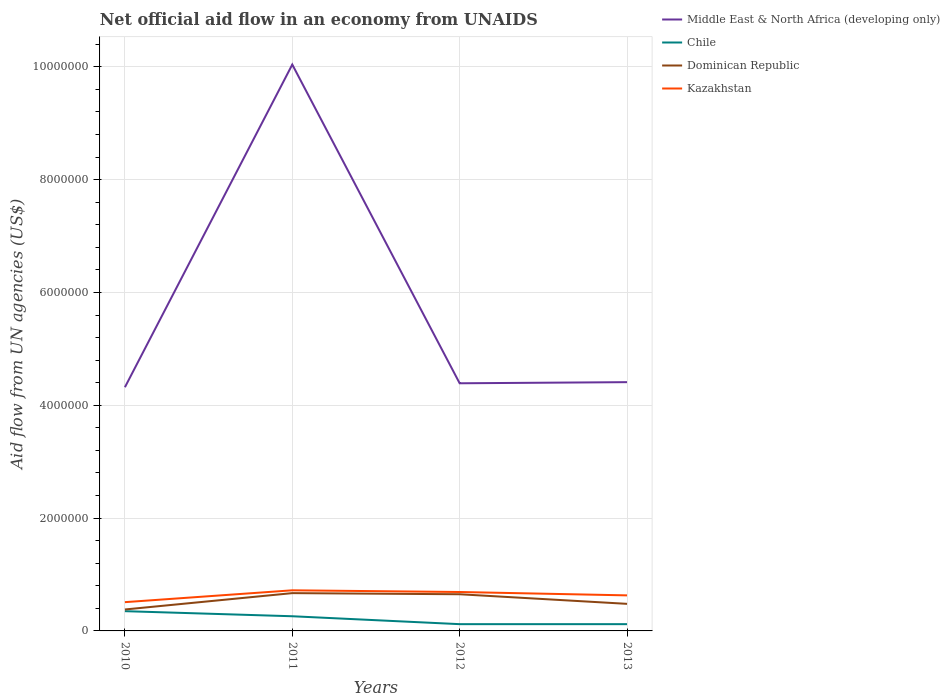Does the line corresponding to Chile intersect with the line corresponding to Middle East & North Africa (developing only)?
Ensure brevity in your answer.  No. Is the number of lines equal to the number of legend labels?
Provide a short and direct response. Yes. Across all years, what is the maximum net official aid flow in Dominican Republic?
Provide a short and direct response. 3.80e+05. What is the total net official aid flow in Kazakhstan in the graph?
Keep it short and to the point. 3.00e+04. What is the difference between the highest and the second highest net official aid flow in Dominican Republic?
Offer a very short reply. 2.90e+05. How many lines are there?
Offer a terse response. 4. How many years are there in the graph?
Provide a short and direct response. 4. What is the difference between two consecutive major ticks on the Y-axis?
Offer a very short reply. 2.00e+06. Are the values on the major ticks of Y-axis written in scientific E-notation?
Your answer should be very brief. No. Does the graph contain grids?
Make the answer very short. Yes. What is the title of the graph?
Offer a terse response. Net official aid flow in an economy from UNAIDS. Does "Eritrea" appear as one of the legend labels in the graph?
Keep it short and to the point. No. What is the label or title of the Y-axis?
Provide a short and direct response. Aid flow from UN agencies (US$). What is the Aid flow from UN agencies (US$) of Middle East & North Africa (developing only) in 2010?
Give a very brief answer. 4.32e+06. What is the Aid flow from UN agencies (US$) in Kazakhstan in 2010?
Ensure brevity in your answer.  5.10e+05. What is the Aid flow from UN agencies (US$) of Middle East & North Africa (developing only) in 2011?
Make the answer very short. 1.00e+07. What is the Aid flow from UN agencies (US$) of Dominican Republic in 2011?
Provide a succinct answer. 6.70e+05. What is the Aid flow from UN agencies (US$) of Kazakhstan in 2011?
Your answer should be compact. 7.20e+05. What is the Aid flow from UN agencies (US$) of Middle East & North Africa (developing only) in 2012?
Your answer should be compact. 4.39e+06. What is the Aid flow from UN agencies (US$) of Dominican Republic in 2012?
Keep it short and to the point. 6.50e+05. What is the Aid flow from UN agencies (US$) of Kazakhstan in 2012?
Provide a short and direct response. 6.90e+05. What is the Aid flow from UN agencies (US$) in Middle East & North Africa (developing only) in 2013?
Offer a very short reply. 4.41e+06. What is the Aid flow from UN agencies (US$) of Chile in 2013?
Give a very brief answer. 1.20e+05. What is the Aid flow from UN agencies (US$) in Dominican Republic in 2013?
Give a very brief answer. 4.80e+05. What is the Aid flow from UN agencies (US$) of Kazakhstan in 2013?
Offer a very short reply. 6.30e+05. Across all years, what is the maximum Aid flow from UN agencies (US$) in Middle East & North Africa (developing only)?
Give a very brief answer. 1.00e+07. Across all years, what is the maximum Aid flow from UN agencies (US$) in Chile?
Keep it short and to the point. 3.50e+05. Across all years, what is the maximum Aid flow from UN agencies (US$) of Dominican Republic?
Your response must be concise. 6.70e+05. Across all years, what is the maximum Aid flow from UN agencies (US$) in Kazakhstan?
Provide a succinct answer. 7.20e+05. Across all years, what is the minimum Aid flow from UN agencies (US$) of Middle East & North Africa (developing only)?
Provide a succinct answer. 4.32e+06. Across all years, what is the minimum Aid flow from UN agencies (US$) in Chile?
Provide a short and direct response. 1.20e+05. Across all years, what is the minimum Aid flow from UN agencies (US$) in Kazakhstan?
Ensure brevity in your answer.  5.10e+05. What is the total Aid flow from UN agencies (US$) in Middle East & North Africa (developing only) in the graph?
Provide a short and direct response. 2.32e+07. What is the total Aid flow from UN agencies (US$) in Chile in the graph?
Ensure brevity in your answer.  8.50e+05. What is the total Aid flow from UN agencies (US$) in Dominican Republic in the graph?
Provide a succinct answer. 2.18e+06. What is the total Aid flow from UN agencies (US$) of Kazakhstan in the graph?
Your answer should be very brief. 2.55e+06. What is the difference between the Aid flow from UN agencies (US$) in Middle East & North Africa (developing only) in 2010 and that in 2011?
Your answer should be compact. -5.72e+06. What is the difference between the Aid flow from UN agencies (US$) in Dominican Republic in 2010 and that in 2011?
Ensure brevity in your answer.  -2.90e+05. What is the difference between the Aid flow from UN agencies (US$) in Kazakhstan in 2010 and that in 2011?
Your answer should be compact. -2.10e+05. What is the difference between the Aid flow from UN agencies (US$) of Dominican Republic in 2010 and that in 2012?
Make the answer very short. -2.70e+05. What is the difference between the Aid flow from UN agencies (US$) in Kazakhstan in 2010 and that in 2013?
Provide a succinct answer. -1.20e+05. What is the difference between the Aid flow from UN agencies (US$) in Middle East & North Africa (developing only) in 2011 and that in 2012?
Your response must be concise. 5.65e+06. What is the difference between the Aid flow from UN agencies (US$) of Kazakhstan in 2011 and that in 2012?
Make the answer very short. 3.00e+04. What is the difference between the Aid flow from UN agencies (US$) in Middle East & North Africa (developing only) in 2011 and that in 2013?
Offer a terse response. 5.63e+06. What is the difference between the Aid flow from UN agencies (US$) of Chile in 2011 and that in 2013?
Ensure brevity in your answer.  1.40e+05. What is the difference between the Aid flow from UN agencies (US$) in Middle East & North Africa (developing only) in 2012 and that in 2013?
Your response must be concise. -2.00e+04. What is the difference between the Aid flow from UN agencies (US$) in Chile in 2012 and that in 2013?
Give a very brief answer. 0. What is the difference between the Aid flow from UN agencies (US$) of Kazakhstan in 2012 and that in 2013?
Give a very brief answer. 6.00e+04. What is the difference between the Aid flow from UN agencies (US$) in Middle East & North Africa (developing only) in 2010 and the Aid flow from UN agencies (US$) in Chile in 2011?
Your answer should be very brief. 4.06e+06. What is the difference between the Aid flow from UN agencies (US$) in Middle East & North Africa (developing only) in 2010 and the Aid flow from UN agencies (US$) in Dominican Republic in 2011?
Ensure brevity in your answer.  3.65e+06. What is the difference between the Aid flow from UN agencies (US$) in Middle East & North Africa (developing only) in 2010 and the Aid flow from UN agencies (US$) in Kazakhstan in 2011?
Keep it short and to the point. 3.60e+06. What is the difference between the Aid flow from UN agencies (US$) of Chile in 2010 and the Aid flow from UN agencies (US$) of Dominican Republic in 2011?
Ensure brevity in your answer.  -3.20e+05. What is the difference between the Aid flow from UN agencies (US$) of Chile in 2010 and the Aid flow from UN agencies (US$) of Kazakhstan in 2011?
Keep it short and to the point. -3.70e+05. What is the difference between the Aid flow from UN agencies (US$) in Dominican Republic in 2010 and the Aid flow from UN agencies (US$) in Kazakhstan in 2011?
Your response must be concise. -3.40e+05. What is the difference between the Aid flow from UN agencies (US$) of Middle East & North Africa (developing only) in 2010 and the Aid flow from UN agencies (US$) of Chile in 2012?
Your answer should be compact. 4.20e+06. What is the difference between the Aid flow from UN agencies (US$) of Middle East & North Africa (developing only) in 2010 and the Aid flow from UN agencies (US$) of Dominican Republic in 2012?
Give a very brief answer. 3.67e+06. What is the difference between the Aid flow from UN agencies (US$) in Middle East & North Africa (developing only) in 2010 and the Aid flow from UN agencies (US$) in Kazakhstan in 2012?
Keep it short and to the point. 3.63e+06. What is the difference between the Aid flow from UN agencies (US$) in Dominican Republic in 2010 and the Aid flow from UN agencies (US$) in Kazakhstan in 2012?
Your answer should be very brief. -3.10e+05. What is the difference between the Aid flow from UN agencies (US$) of Middle East & North Africa (developing only) in 2010 and the Aid flow from UN agencies (US$) of Chile in 2013?
Offer a very short reply. 4.20e+06. What is the difference between the Aid flow from UN agencies (US$) in Middle East & North Africa (developing only) in 2010 and the Aid flow from UN agencies (US$) in Dominican Republic in 2013?
Ensure brevity in your answer.  3.84e+06. What is the difference between the Aid flow from UN agencies (US$) in Middle East & North Africa (developing only) in 2010 and the Aid flow from UN agencies (US$) in Kazakhstan in 2013?
Provide a succinct answer. 3.69e+06. What is the difference between the Aid flow from UN agencies (US$) of Chile in 2010 and the Aid flow from UN agencies (US$) of Kazakhstan in 2013?
Your response must be concise. -2.80e+05. What is the difference between the Aid flow from UN agencies (US$) of Dominican Republic in 2010 and the Aid flow from UN agencies (US$) of Kazakhstan in 2013?
Offer a terse response. -2.50e+05. What is the difference between the Aid flow from UN agencies (US$) of Middle East & North Africa (developing only) in 2011 and the Aid flow from UN agencies (US$) of Chile in 2012?
Your answer should be compact. 9.92e+06. What is the difference between the Aid flow from UN agencies (US$) of Middle East & North Africa (developing only) in 2011 and the Aid flow from UN agencies (US$) of Dominican Republic in 2012?
Keep it short and to the point. 9.39e+06. What is the difference between the Aid flow from UN agencies (US$) of Middle East & North Africa (developing only) in 2011 and the Aid flow from UN agencies (US$) of Kazakhstan in 2012?
Make the answer very short. 9.35e+06. What is the difference between the Aid flow from UN agencies (US$) in Chile in 2011 and the Aid flow from UN agencies (US$) in Dominican Republic in 2012?
Provide a succinct answer. -3.90e+05. What is the difference between the Aid flow from UN agencies (US$) of Chile in 2011 and the Aid flow from UN agencies (US$) of Kazakhstan in 2012?
Your response must be concise. -4.30e+05. What is the difference between the Aid flow from UN agencies (US$) of Dominican Republic in 2011 and the Aid flow from UN agencies (US$) of Kazakhstan in 2012?
Ensure brevity in your answer.  -2.00e+04. What is the difference between the Aid flow from UN agencies (US$) of Middle East & North Africa (developing only) in 2011 and the Aid flow from UN agencies (US$) of Chile in 2013?
Your answer should be compact. 9.92e+06. What is the difference between the Aid flow from UN agencies (US$) in Middle East & North Africa (developing only) in 2011 and the Aid flow from UN agencies (US$) in Dominican Republic in 2013?
Provide a short and direct response. 9.56e+06. What is the difference between the Aid flow from UN agencies (US$) in Middle East & North Africa (developing only) in 2011 and the Aid flow from UN agencies (US$) in Kazakhstan in 2013?
Keep it short and to the point. 9.41e+06. What is the difference between the Aid flow from UN agencies (US$) of Chile in 2011 and the Aid flow from UN agencies (US$) of Kazakhstan in 2013?
Make the answer very short. -3.70e+05. What is the difference between the Aid flow from UN agencies (US$) of Dominican Republic in 2011 and the Aid flow from UN agencies (US$) of Kazakhstan in 2013?
Provide a short and direct response. 4.00e+04. What is the difference between the Aid flow from UN agencies (US$) in Middle East & North Africa (developing only) in 2012 and the Aid flow from UN agencies (US$) in Chile in 2013?
Make the answer very short. 4.27e+06. What is the difference between the Aid flow from UN agencies (US$) of Middle East & North Africa (developing only) in 2012 and the Aid flow from UN agencies (US$) of Dominican Republic in 2013?
Give a very brief answer. 3.91e+06. What is the difference between the Aid flow from UN agencies (US$) of Middle East & North Africa (developing only) in 2012 and the Aid flow from UN agencies (US$) of Kazakhstan in 2013?
Keep it short and to the point. 3.76e+06. What is the difference between the Aid flow from UN agencies (US$) in Chile in 2012 and the Aid flow from UN agencies (US$) in Dominican Republic in 2013?
Your response must be concise. -3.60e+05. What is the difference between the Aid flow from UN agencies (US$) of Chile in 2012 and the Aid flow from UN agencies (US$) of Kazakhstan in 2013?
Your response must be concise. -5.10e+05. What is the difference between the Aid flow from UN agencies (US$) in Dominican Republic in 2012 and the Aid flow from UN agencies (US$) in Kazakhstan in 2013?
Keep it short and to the point. 2.00e+04. What is the average Aid flow from UN agencies (US$) of Middle East & North Africa (developing only) per year?
Provide a succinct answer. 5.79e+06. What is the average Aid flow from UN agencies (US$) of Chile per year?
Offer a terse response. 2.12e+05. What is the average Aid flow from UN agencies (US$) in Dominican Republic per year?
Keep it short and to the point. 5.45e+05. What is the average Aid flow from UN agencies (US$) in Kazakhstan per year?
Give a very brief answer. 6.38e+05. In the year 2010, what is the difference between the Aid flow from UN agencies (US$) of Middle East & North Africa (developing only) and Aid flow from UN agencies (US$) of Chile?
Your response must be concise. 3.97e+06. In the year 2010, what is the difference between the Aid flow from UN agencies (US$) of Middle East & North Africa (developing only) and Aid flow from UN agencies (US$) of Dominican Republic?
Offer a very short reply. 3.94e+06. In the year 2010, what is the difference between the Aid flow from UN agencies (US$) in Middle East & North Africa (developing only) and Aid flow from UN agencies (US$) in Kazakhstan?
Provide a succinct answer. 3.81e+06. In the year 2010, what is the difference between the Aid flow from UN agencies (US$) in Chile and Aid flow from UN agencies (US$) in Kazakhstan?
Ensure brevity in your answer.  -1.60e+05. In the year 2010, what is the difference between the Aid flow from UN agencies (US$) in Dominican Republic and Aid flow from UN agencies (US$) in Kazakhstan?
Offer a terse response. -1.30e+05. In the year 2011, what is the difference between the Aid flow from UN agencies (US$) of Middle East & North Africa (developing only) and Aid flow from UN agencies (US$) of Chile?
Ensure brevity in your answer.  9.78e+06. In the year 2011, what is the difference between the Aid flow from UN agencies (US$) in Middle East & North Africa (developing only) and Aid flow from UN agencies (US$) in Dominican Republic?
Keep it short and to the point. 9.37e+06. In the year 2011, what is the difference between the Aid flow from UN agencies (US$) in Middle East & North Africa (developing only) and Aid flow from UN agencies (US$) in Kazakhstan?
Make the answer very short. 9.32e+06. In the year 2011, what is the difference between the Aid flow from UN agencies (US$) of Chile and Aid flow from UN agencies (US$) of Dominican Republic?
Provide a short and direct response. -4.10e+05. In the year 2011, what is the difference between the Aid flow from UN agencies (US$) in Chile and Aid flow from UN agencies (US$) in Kazakhstan?
Your answer should be very brief. -4.60e+05. In the year 2011, what is the difference between the Aid flow from UN agencies (US$) of Dominican Republic and Aid flow from UN agencies (US$) of Kazakhstan?
Offer a terse response. -5.00e+04. In the year 2012, what is the difference between the Aid flow from UN agencies (US$) in Middle East & North Africa (developing only) and Aid flow from UN agencies (US$) in Chile?
Give a very brief answer. 4.27e+06. In the year 2012, what is the difference between the Aid flow from UN agencies (US$) of Middle East & North Africa (developing only) and Aid flow from UN agencies (US$) of Dominican Republic?
Your answer should be very brief. 3.74e+06. In the year 2012, what is the difference between the Aid flow from UN agencies (US$) in Middle East & North Africa (developing only) and Aid flow from UN agencies (US$) in Kazakhstan?
Your response must be concise. 3.70e+06. In the year 2012, what is the difference between the Aid flow from UN agencies (US$) of Chile and Aid flow from UN agencies (US$) of Dominican Republic?
Make the answer very short. -5.30e+05. In the year 2012, what is the difference between the Aid flow from UN agencies (US$) of Chile and Aid flow from UN agencies (US$) of Kazakhstan?
Your answer should be compact. -5.70e+05. In the year 2013, what is the difference between the Aid flow from UN agencies (US$) of Middle East & North Africa (developing only) and Aid flow from UN agencies (US$) of Chile?
Provide a short and direct response. 4.29e+06. In the year 2013, what is the difference between the Aid flow from UN agencies (US$) of Middle East & North Africa (developing only) and Aid flow from UN agencies (US$) of Dominican Republic?
Your answer should be compact. 3.93e+06. In the year 2013, what is the difference between the Aid flow from UN agencies (US$) in Middle East & North Africa (developing only) and Aid flow from UN agencies (US$) in Kazakhstan?
Offer a terse response. 3.78e+06. In the year 2013, what is the difference between the Aid flow from UN agencies (US$) of Chile and Aid flow from UN agencies (US$) of Dominican Republic?
Your answer should be very brief. -3.60e+05. In the year 2013, what is the difference between the Aid flow from UN agencies (US$) in Chile and Aid flow from UN agencies (US$) in Kazakhstan?
Offer a terse response. -5.10e+05. In the year 2013, what is the difference between the Aid flow from UN agencies (US$) of Dominican Republic and Aid flow from UN agencies (US$) of Kazakhstan?
Provide a short and direct response. -1.50e+05. What is the ratio of the Aid flow from UN agencies (US$) in Middle East & North Africa (developing only) in 2010 to that in 2011?
Keep it short and to the point. 0.43. What is the ratio of the Aid flow from UN agencies (US$) of Chile in 2010 to that in 2011?
Provide a short and direct response. 1.35. What is the ratio of the Aid flow from UN agencies (US$) of Dominican Republic in 2010 to that in 2011?
Give a very brief answer. 0.57. What is the ratio of the Aid flow from UN agencies (US$) of Kazakhstan in 2010 to that in 2011?
Your response must be concise. 0.71. What is the ratio of the Aid flow from UN agencies (US$) in Middle East & North Africa (developing only) in 2010 to that in 2012?
Offer a terse response. 0.98. What is the ratio of the Aid flow from UN agencies (US$) of Chile in 2010 to that in 2012?
Make the answer very short. 2.92. What is the ratio of the Aid flow from UN agencies (US$) in Dominican Republic in 2010 to that in 2012?
Provide a succinct answer. 0.58. What is the ratio of the Aid flow from UN agencies (US$) of Kazakhstan in 2010 to that in 2012?
Your answer should be very brief. 0.74. What is the ratio of the Aid flow from UN agencies (US$) of Middle East & North Africa (developing only) in 2010 to that in 2013?
Offer a terse response. 0.98. What is the ratio of the Aid flow from UN agencies (US$) of Chile in 2010 to that in 2013?
Provide a short and direct response. 2.92. What is the ratio of the Aid flow from UN agencies (US$) in Dominican Republic in 2010 to that in 2013?
Ensure brevity in your answer.  0.79. What is the ratio of the Aid flow from UN agencies (US$) of Kazakhstan in 2010 to that in 2013?
Offer a very short reply. 0.81. What is the ratio of the Aid flow from UN agencies (US$) in Middle East & North Africa (developing only) in 2011 to that in 2012?
Make the answer very short. 2.29. What is the ratio of the Aid flow from UN agencies (US$) in Chile in 2011 to that in 2012?
Keep it short and to the point. 2.17. What is the ratio of the Aid flow from UN agencies (US$) of Dominican Republic in 2011 to that in 2012?
Your answer should be compact. 1.03. What is the ratio of the Aid flow from UN agencies (US$) of Kazakhstan in 2011 to that in 2012?
Your answer should be compact. 1.04. What is the ratio of the Aid flow from UN agencies (US$) of Middle East & North Africa (developing only) in 2011 to that in 2013?
Offer a terse response. 2.28. What is the ratio of the Aid flow from UN agencies (US$) of Chile in 2011 to that in 2013?
Keep it short and to the point. 2.17. What is the ratio of the Aid flow from UN agencies (US$) in Dominican Republic in 2011 to that in 2013?
Give a very brief answer. 1.4. What is the ratio of the Aid flow from UN agencies (US$) in Kazakhstan in 2011 to that in 2013?
Provide a short and direct response. 1.14. What is the ratio of the Aid flow from UN agencies (US$) of Chile in 2012 to that in 2013?
Provide a short and direct response. 1. What is the ratio of the Aid flow from UN agencies (US$) of Dominican Republic in 2012 to that in 2013?
Ensure brevity in your answer.  1.35. What is the ratio of the Aid flow from UN agencies (US$) in Kazakhstan in 2012 to that in 2013?
Give a very brief answer. 1.1. What is the difference between the highest and the second highest Aid flow from UN agencies (US$) in Middle East & North Africa (developing only)?
Offer a very short reply. 5.63e+06. What is the difference between the highest and the second highest Aid flow from UN agencies (US$) of Chile?
Offer a very short reply. 9.00e+04. What is the difference between the highest and the second highest Aid flow from UN agencies (US$) in Dominican Republic?
Give a very brief answer. 2.00e+04. What is the difference between the highest and the lowest Aid flow from UN agencies (US$) of Middle East & North Africa (developing only)?
Give a very brief answer. 5.72e+06. What is the difference between the highest and the lowest Aid flow from UN agencies (US$) of Chile?
Provide a short and direct response. 2.30e+05. What is the difference between the highest and the lowest Aid flow from UN agencies (US$) of Dominican Republic?
Give a very brief answer. 2.90e+05. 